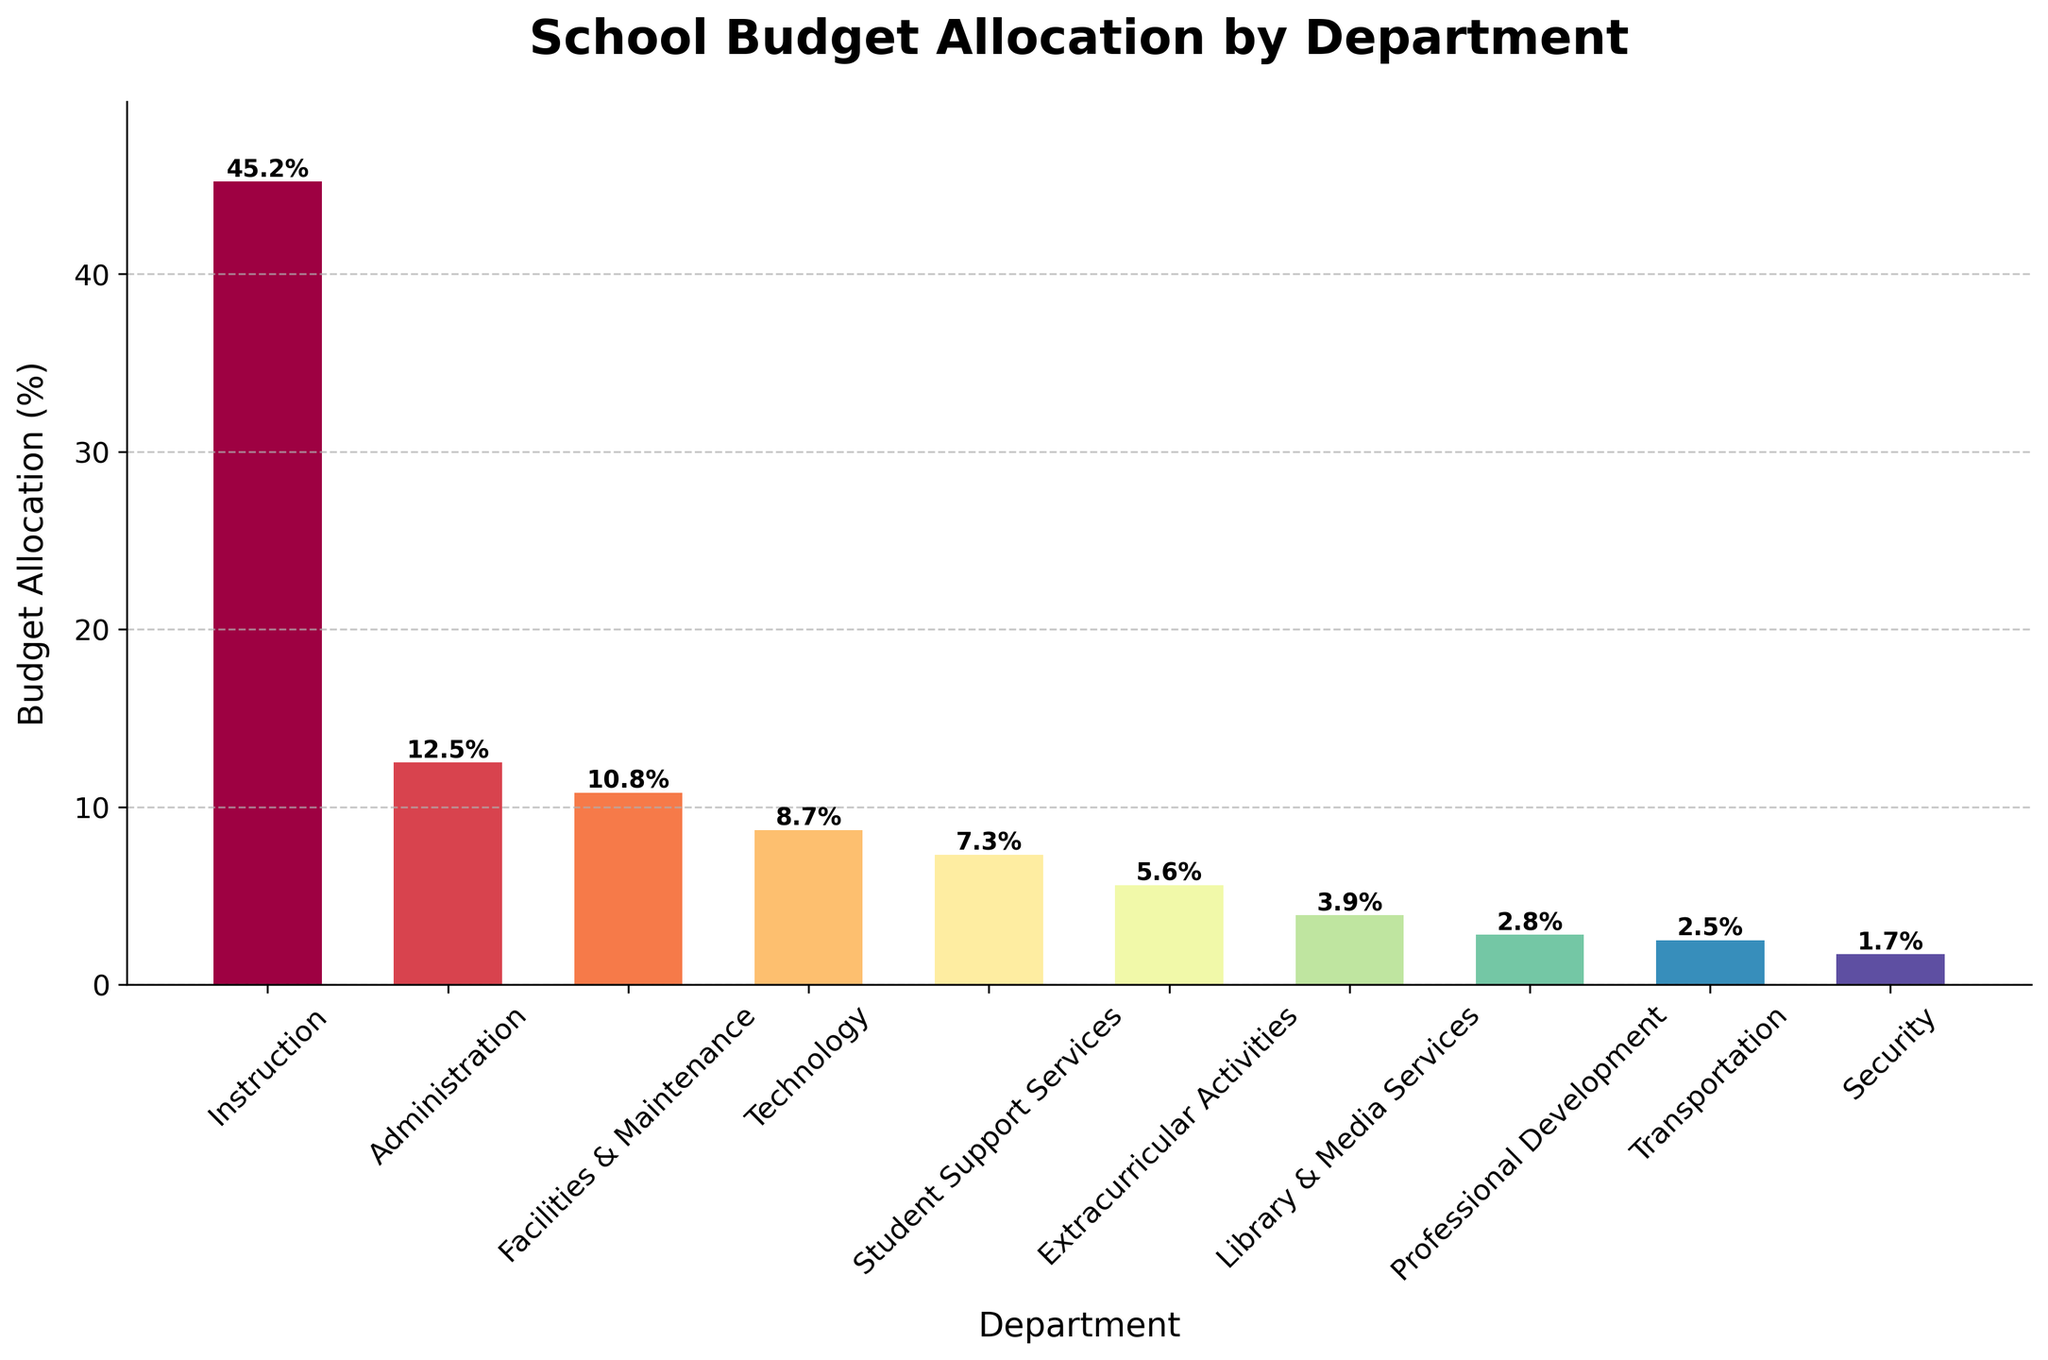What's the budget allocation for the Transportation department? Identify the bar representing the Transportation department. The label shows 2.5%.
Answer: 2.5% Which department receives the highest budget allocation? Identify the tallest bar in the bar chart. The label shows that the tallest bar represents the Instruction department with 45.2%.
Answer: Instruction How much more budget is allocated to Facilities & Maintenance compared to Security? Find the heights of the bars for Facilities & Maintenance and Security. Facilities & Maintenance has 10.8% and Security has 1.7%. The difference is 10.8% - 1.7% = 9.1%.
Answer: 9.1% What is the combined budget allocation for Technology and Library & Media Services? Identify the heights of the bars for Technology and Library & Media Services. Technology is 8.7% and Library & Media Services is 3.9%. The combined allocation is 8.7% + 3.9% = 12.6%.
Answer: 12.6% Which departments receive less than 5% of the total budget? Identify all the bars with heights less than 5%. These bars represent Library & Media Services (3.9%), Professional Development (2.8%), Transportation (2.5%), and Security (1.7%).
Answer: Library & Media Services, Professional Development, Transportation, Security Compare the budget allocation between Student Support Services and Extracurricular Activities. Which one is higher and by how much? Identify the bars for Student Support Services and Extracurricular Activities. Student Support Services is 7.3% and Extracurricular Activities is 5.6%. Student Support Services is higher by 7.3% - 5.6% = 1.7%.
Answer: Student Support Services by 1.7% Is the budget allocation for Administration more than double that of Professional Development? Find the allocation for Administration (12.5%) and Professional Development (2.8%). Calculate twice the allocation of Professional Development (2.8% * 2 = 5.6%). Since 12.5% is more than 5.6%, the allocation for Administration is indeed more than double that of Professional Development.
Answer: Yes What is the percentage difference between the highest and the lowest budget allocations? Identify the highest (Instruction at 45.2%) and lowest (Security at 1.7%) allocations. The percentage difference is 45.2% - 1.7% = 43.5%.
Answer: 43.5% What is the average budget allocation across all departments? Sum up all the allocations: 45.2% + 12.5% + 10.8% + 8.7% + 7.3% + 5.6% + 3.9% + 2.8% + 2.5% + 1.7% = 101%; divide by the number of departments (10). The average is 101% / 10 = 10.1%.
Answer: 10.1% 